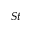<formula> <loc_0><loc_0><loc_500><loc_500>S t</formula> 